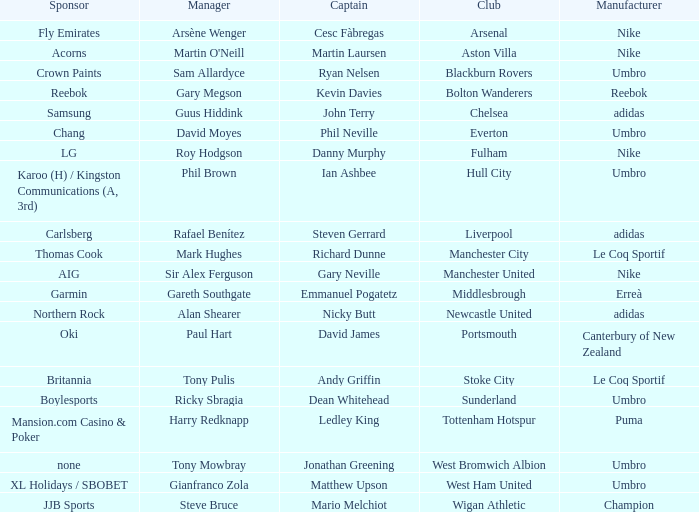What Premier League Manager has an Adidas sponsor and a Newcastle United club? Alan Shearer. 